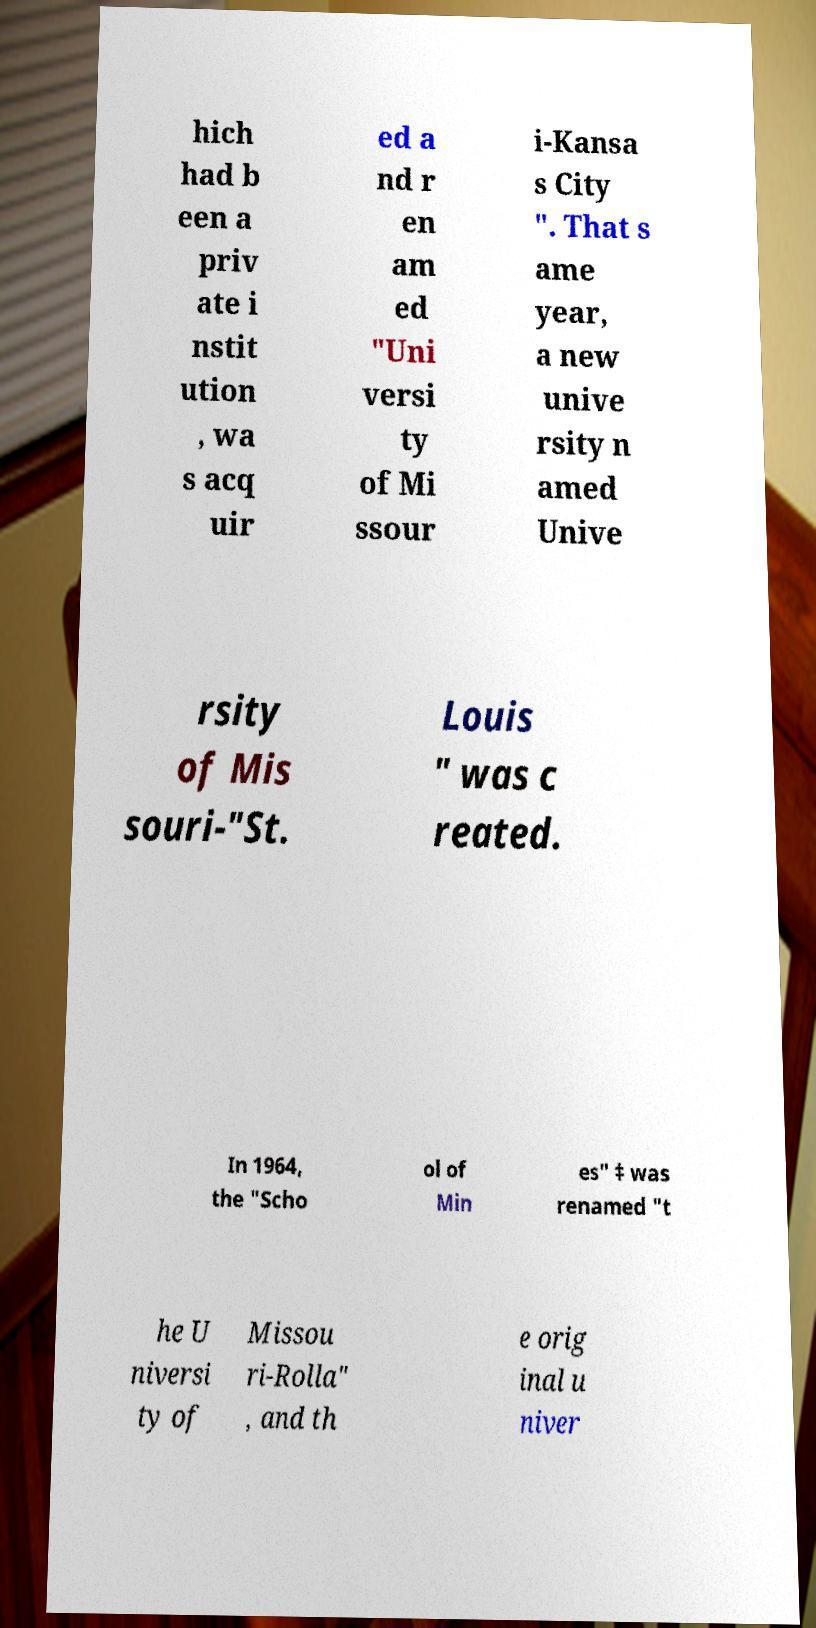Could you assist in decoding the text presented in this image and type it out clearly? hich had b een a priv ate i nstit ution , wa s acq uir ed a nd r en am ed "Uni versi ty of Mi ssour i-Kansa s City ". That s ame year, a new unive rsity n amed Unive rsity of Mis souri-"St. Louis " was c reated. In 1964, the "Scho ol of Min es" ‡ was renamed "t he U niversi ty of Missou ri-Rolla" , and th e orig inal u niver 